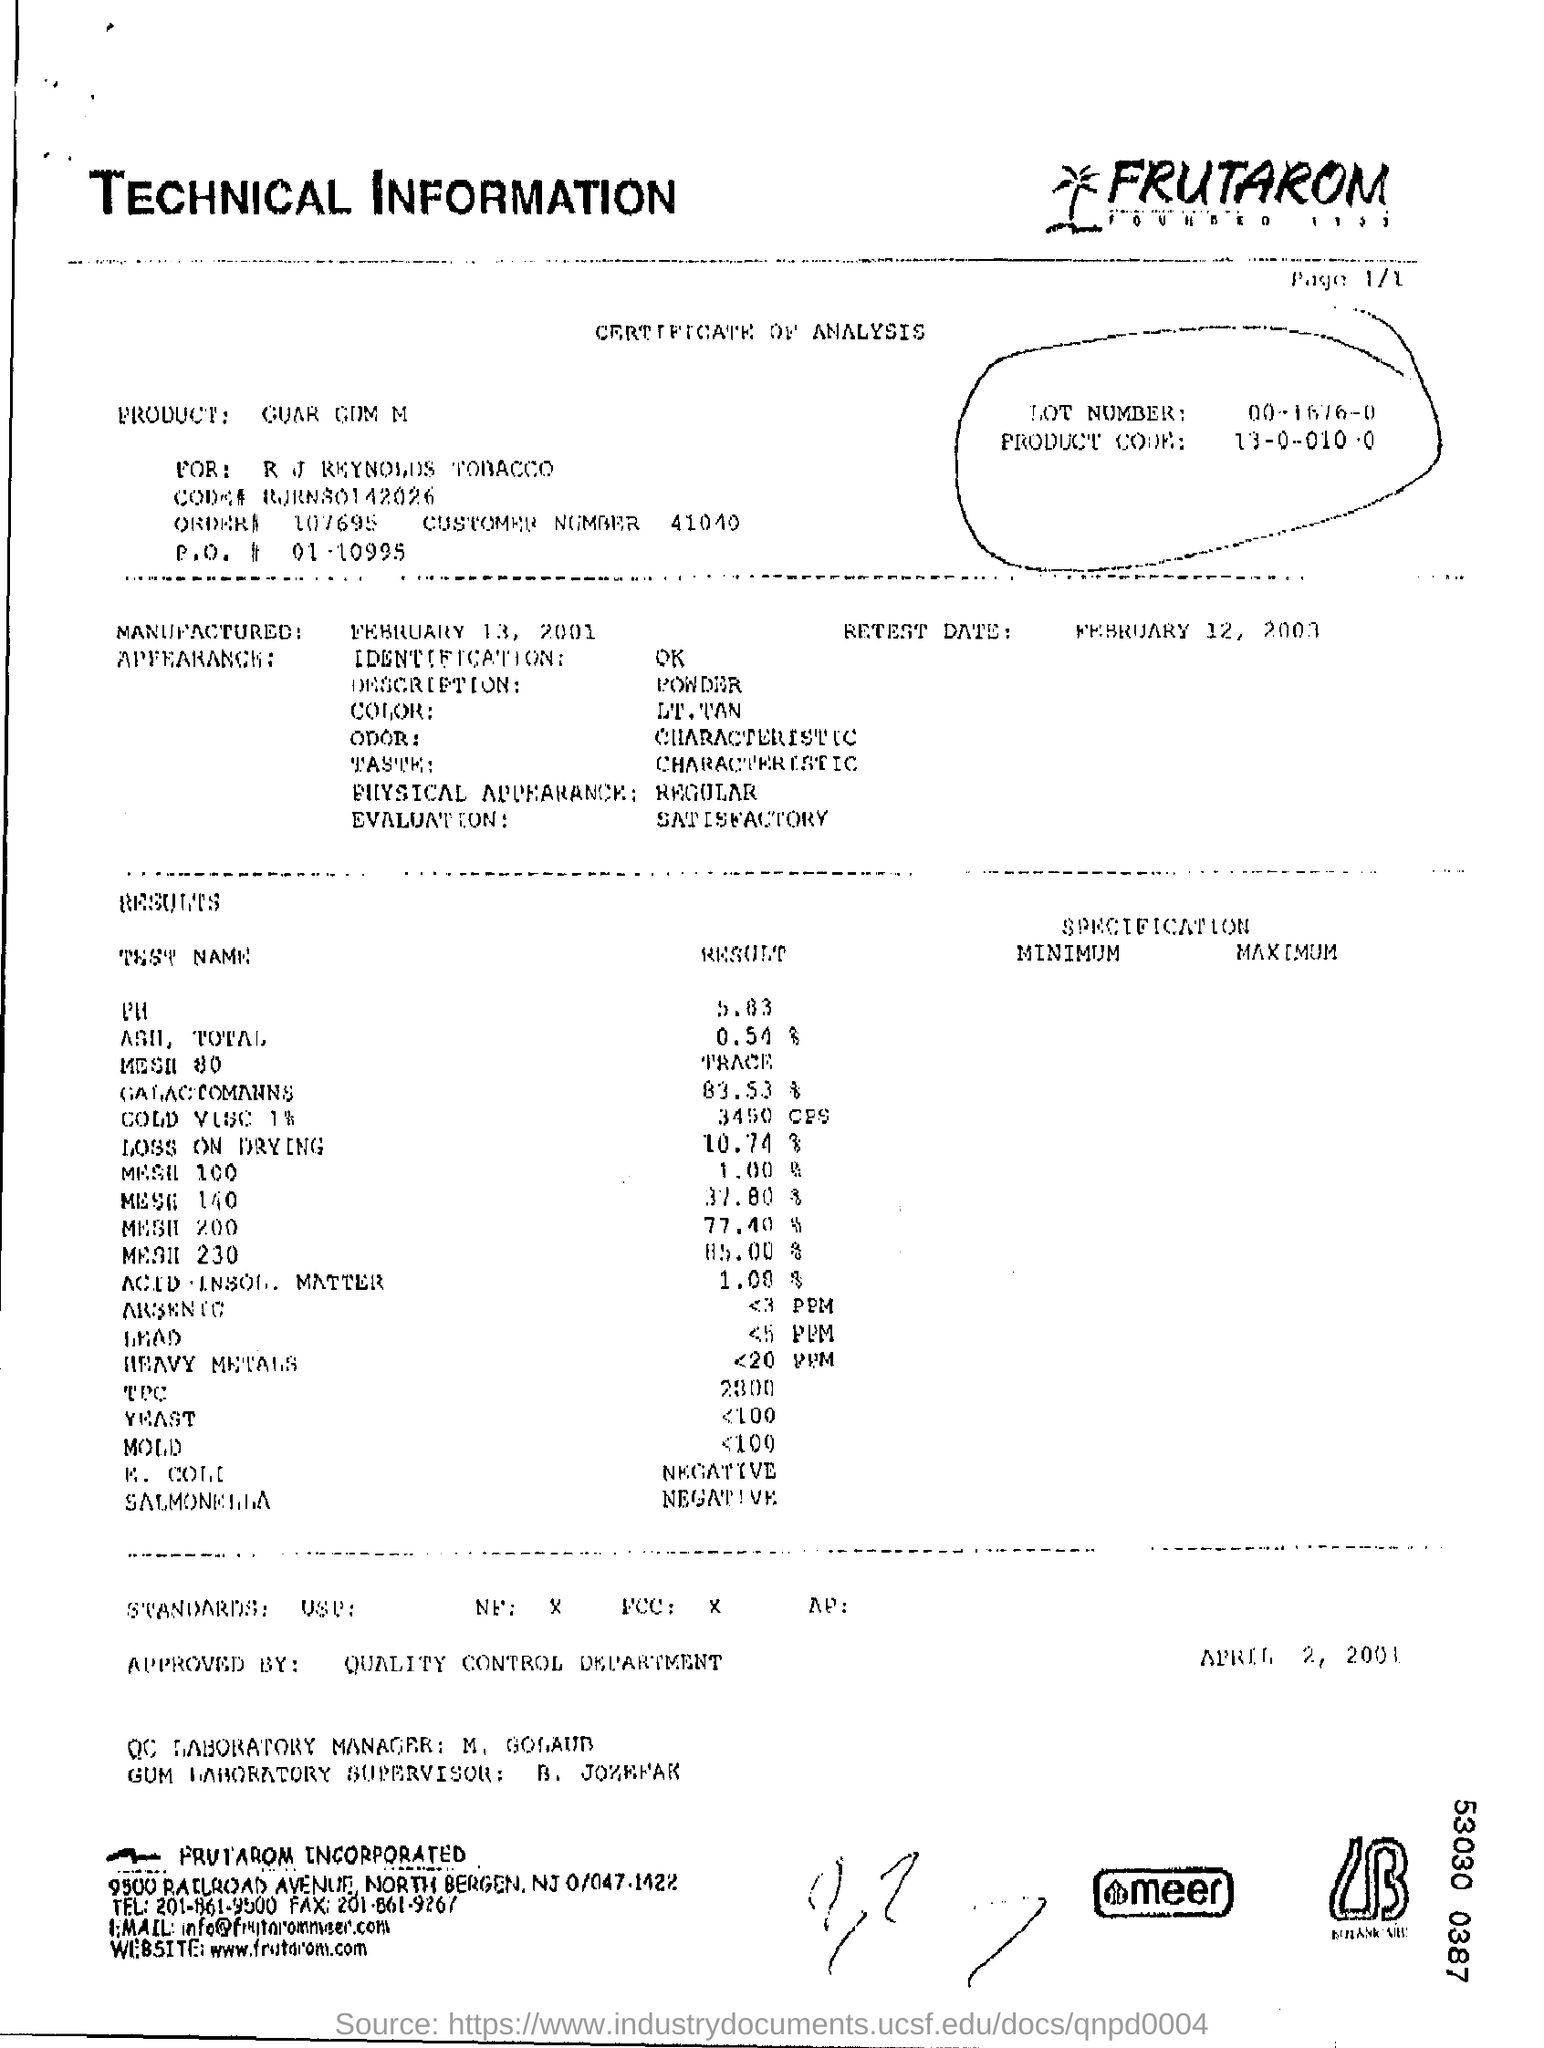What is the Lot Number?
Give a very brief answer. 00-1676-0. What is the Retest Date?
Provide a short and direct response. February 12, 2003. When Is it manufactured?
Keep it short and to the point. February 13, 2001. What is the description?
Offer a terse response. Powder. What is the color?
Keep it short and to the point. LT. TAN. What is the odor?
Provide a short and direct response. Characteristic. What is the Taste?
Your answer should be very brief. Characteristic. What is the Physical appearance?
Make the answer very short. Regular. What is the result for PH?
Your answer should be very brief. 5.83. 